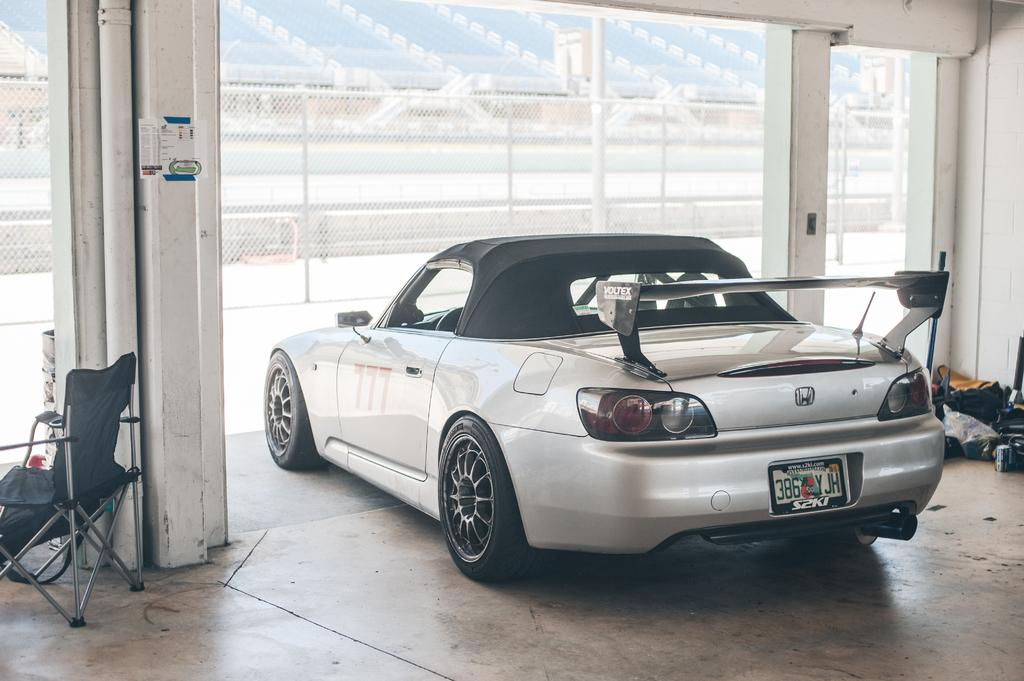What color is the car in the image? The car in the image is white. What is the car doing in the image? The car is parked. What other object can be seen in the image? There is a chair in the image. What else is visible in the image? There are some objects and a fence in the image. What can be seen in the background of the image? There is a stadium in the background of the image. What type of spy equipment can be seen on the car in the image? There is no spy equipment visible on the car in the image. What kind of fang is present on the chair in the image? There are no fangs present on the chair in the image. 